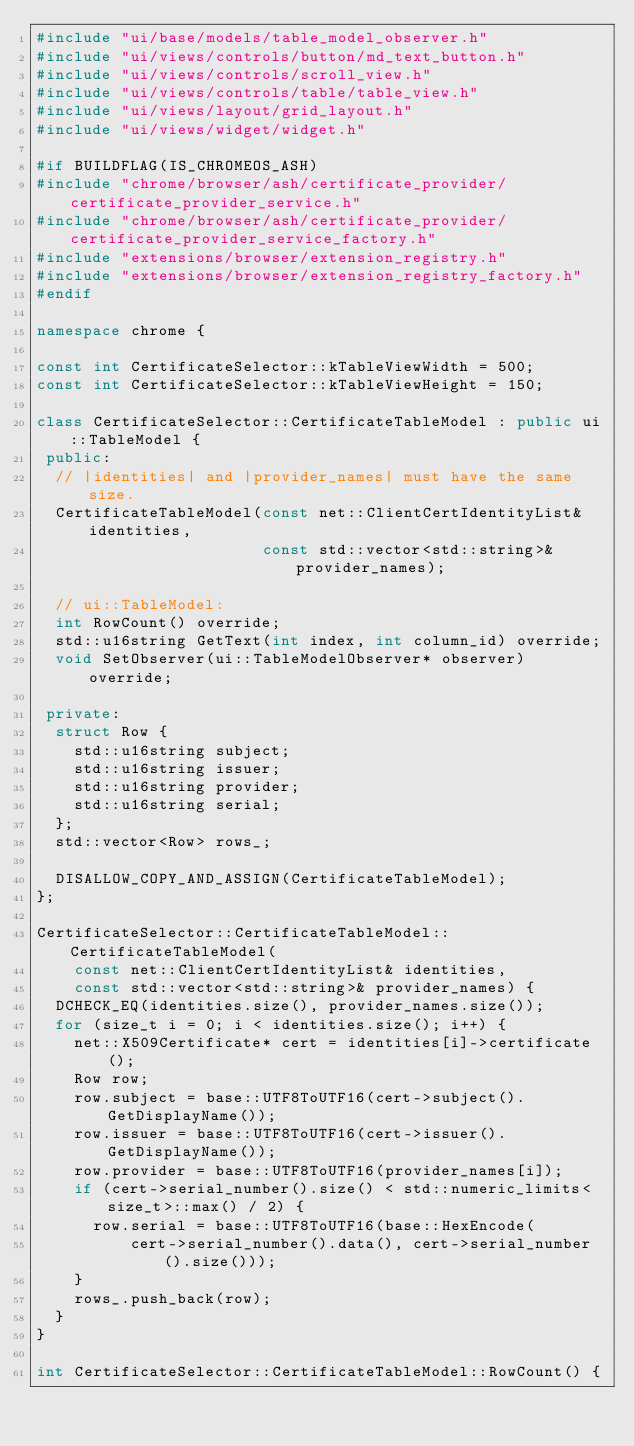<code> <loc_0><loc_0><loc_500><loc_500><_C++_>#include "ui/base/models/table_model_observer.h"
#include "ui/views/controls/button/md_text_button.h"
#include "ui/views/controls/scroll_view.h"
#include "ui/views/controls/table/table_view.h"
#include "ui/views/layout/grid_layout.h"
#include "ui/views/widget/widget.h"

#if BUILDFLAG(IS_CHROMEOS_ASH)
#include "chrome/browser/ash/certificate_provider/certificate_provider_service.h"
#include "chrome/browser/ash/certificate_provider/certificate_provider_service_factory.h"
#include "extensions/browser/extension_registry.h"
#include "extensions/browser/extension_registry_factory.h"
#endif

namespace chrome {

const int CertificateSelector::kTableViewWidth = 500;
const int CertificateSelector::kTableViewHeight = 150;

class CertificateSelector::CertificateTableModel : public ui::TableModel {
 public:
  // |identities| and |provider_names| must have the same size.
  CertificateTableModel(const net::ClientCertIdentityList& identities,
                        const std::vector<std::string>& provider_names);

  // ui::TableModel:
  int RowCount() override;
  std::u16string GetText(int index, int column_id) override;
  void SetObserver(ui::TableModelObserver* observer) override;

 private:
  struct Row {
    std::u16string subject;
    std::u16string issuer;
    std::u16string provider;
    std::u16string serial;
  };
  std::vector<Row> rows_;

  DISALLOW_COPY_AND_ASSIGN(CertificateTableModel);
};

CertificateSelector::CertificateTableModel::CertificateTableModel(
    const net::ClientCertIdentityList& identities,
    const std::vector<std::string>& provider_names) {
  DCHECK_EQ(identities.size(), provider_names.size());
  for (size_t i = 0; i < identities.size(); i++) {
    net::X509Certificate* cert = identities[i]->certificate();
    Row row;
    row.subject = base::UTF8ToUTF16(cert->subject().GetDisplayName());
    row.issuer = base::UTF8ToUTF16(cert->issuer().GetDisplayName());
    row.provider = base::UTF8ToUTF16(provider_names[i]);
    if (cert->serial_number().size() < std::numeric_limits<size_t>::max() / 2) {
      row.serial = base::UTF8ToUTF16(base::HexEncode(
          cert->serial_number().data(), cert->serial_number().size()));
    }
    rows_.push_back(row);
  }
}

int CertificateSelector::CertificateTableModel::RowCount() {</code> 